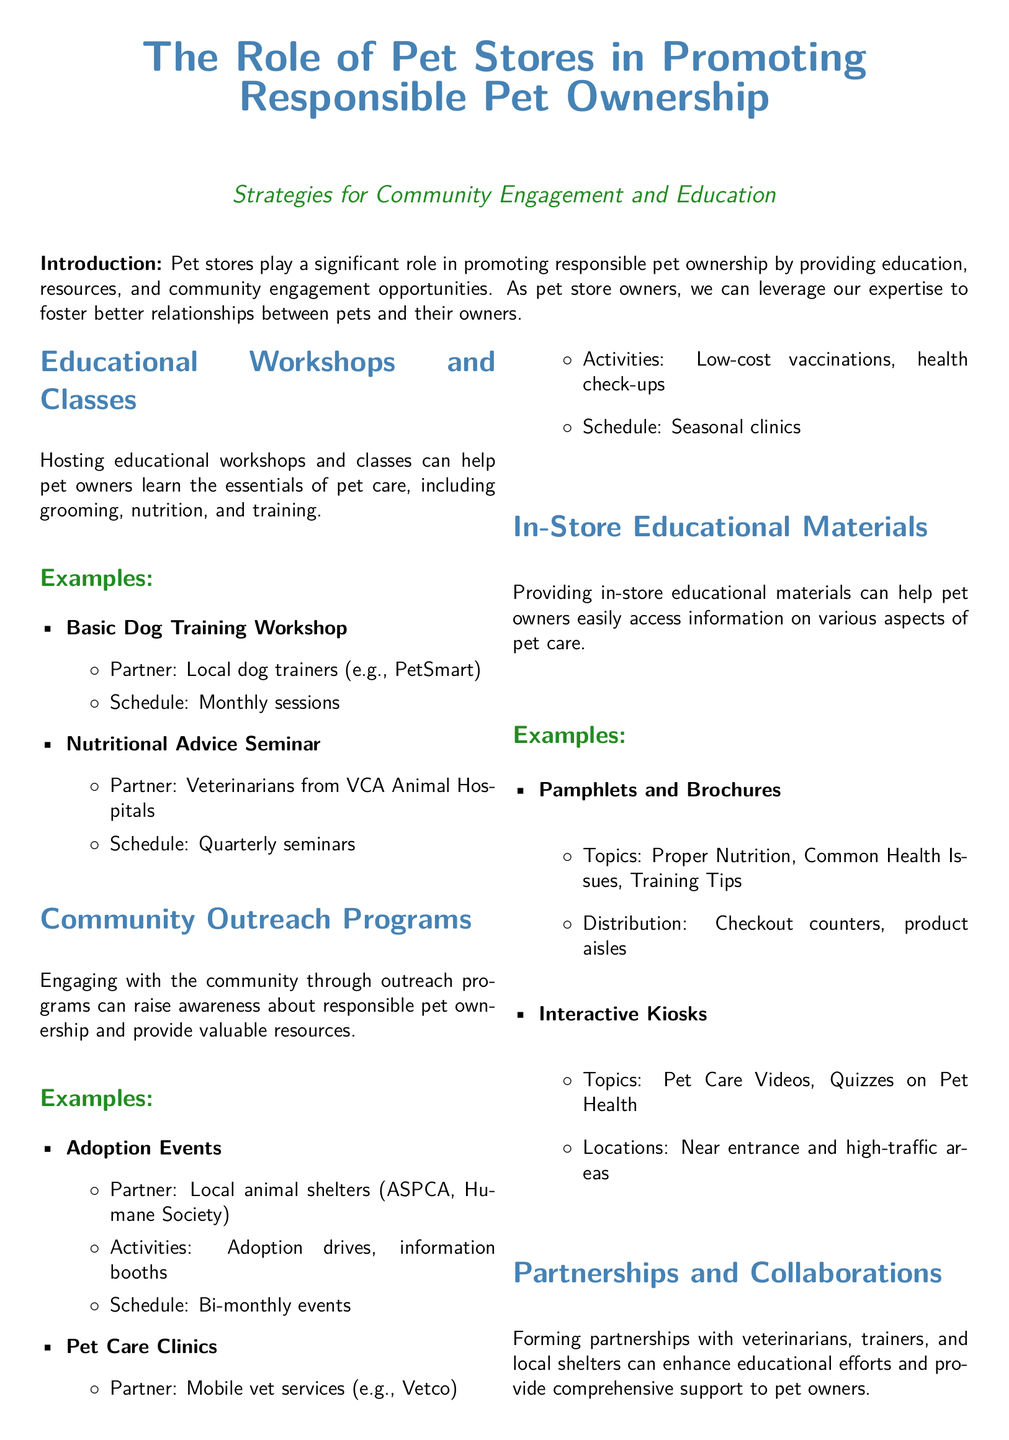what is the title of the whitepaper? The title of the whitepaper is prominently displayed at the top of the document.
Answer: The Role of Pet Stores in Promoting Responsible Pet Ownership how often do the Basic Dog Training Workshops occur? The frequency of the Basic Dog Training Workshops is mentioned in the examples section of educational workshops.
Answer: Monthly sessions who are the partners for the Nutritional Advice Seminar? The partners for the Nutritional Advice Seminar are listed in the related item.
Answer: Veterinarians from VCA Animal Hospitals what type of events are organized bi-monthly according to the document? The document specifies events that engage with the community and lists their frequency in the community outreach section.
Answer: Adoption Events what is one of the types of in-store educational materials mentioned? The document lists various in-store educational materials in its respective section.
Answer: Pamphlets and Brochures which professionals can be guest speakers at the workshops? The document details partnerships that enhance educational efforts, providing examples of who can contribute.
Answer: Local Veterinary Clinics what is the benefit of partnering with Animal Behaviorists? The document explains the advantages of forming partnerships in its partnerships section.
Answer: Expert guidance how many strategies for community engagement and education are listed in the whitepaper? The number of strategies can be identified by counting the major sections presented in the whitepaper.
Answer: Four strategies 